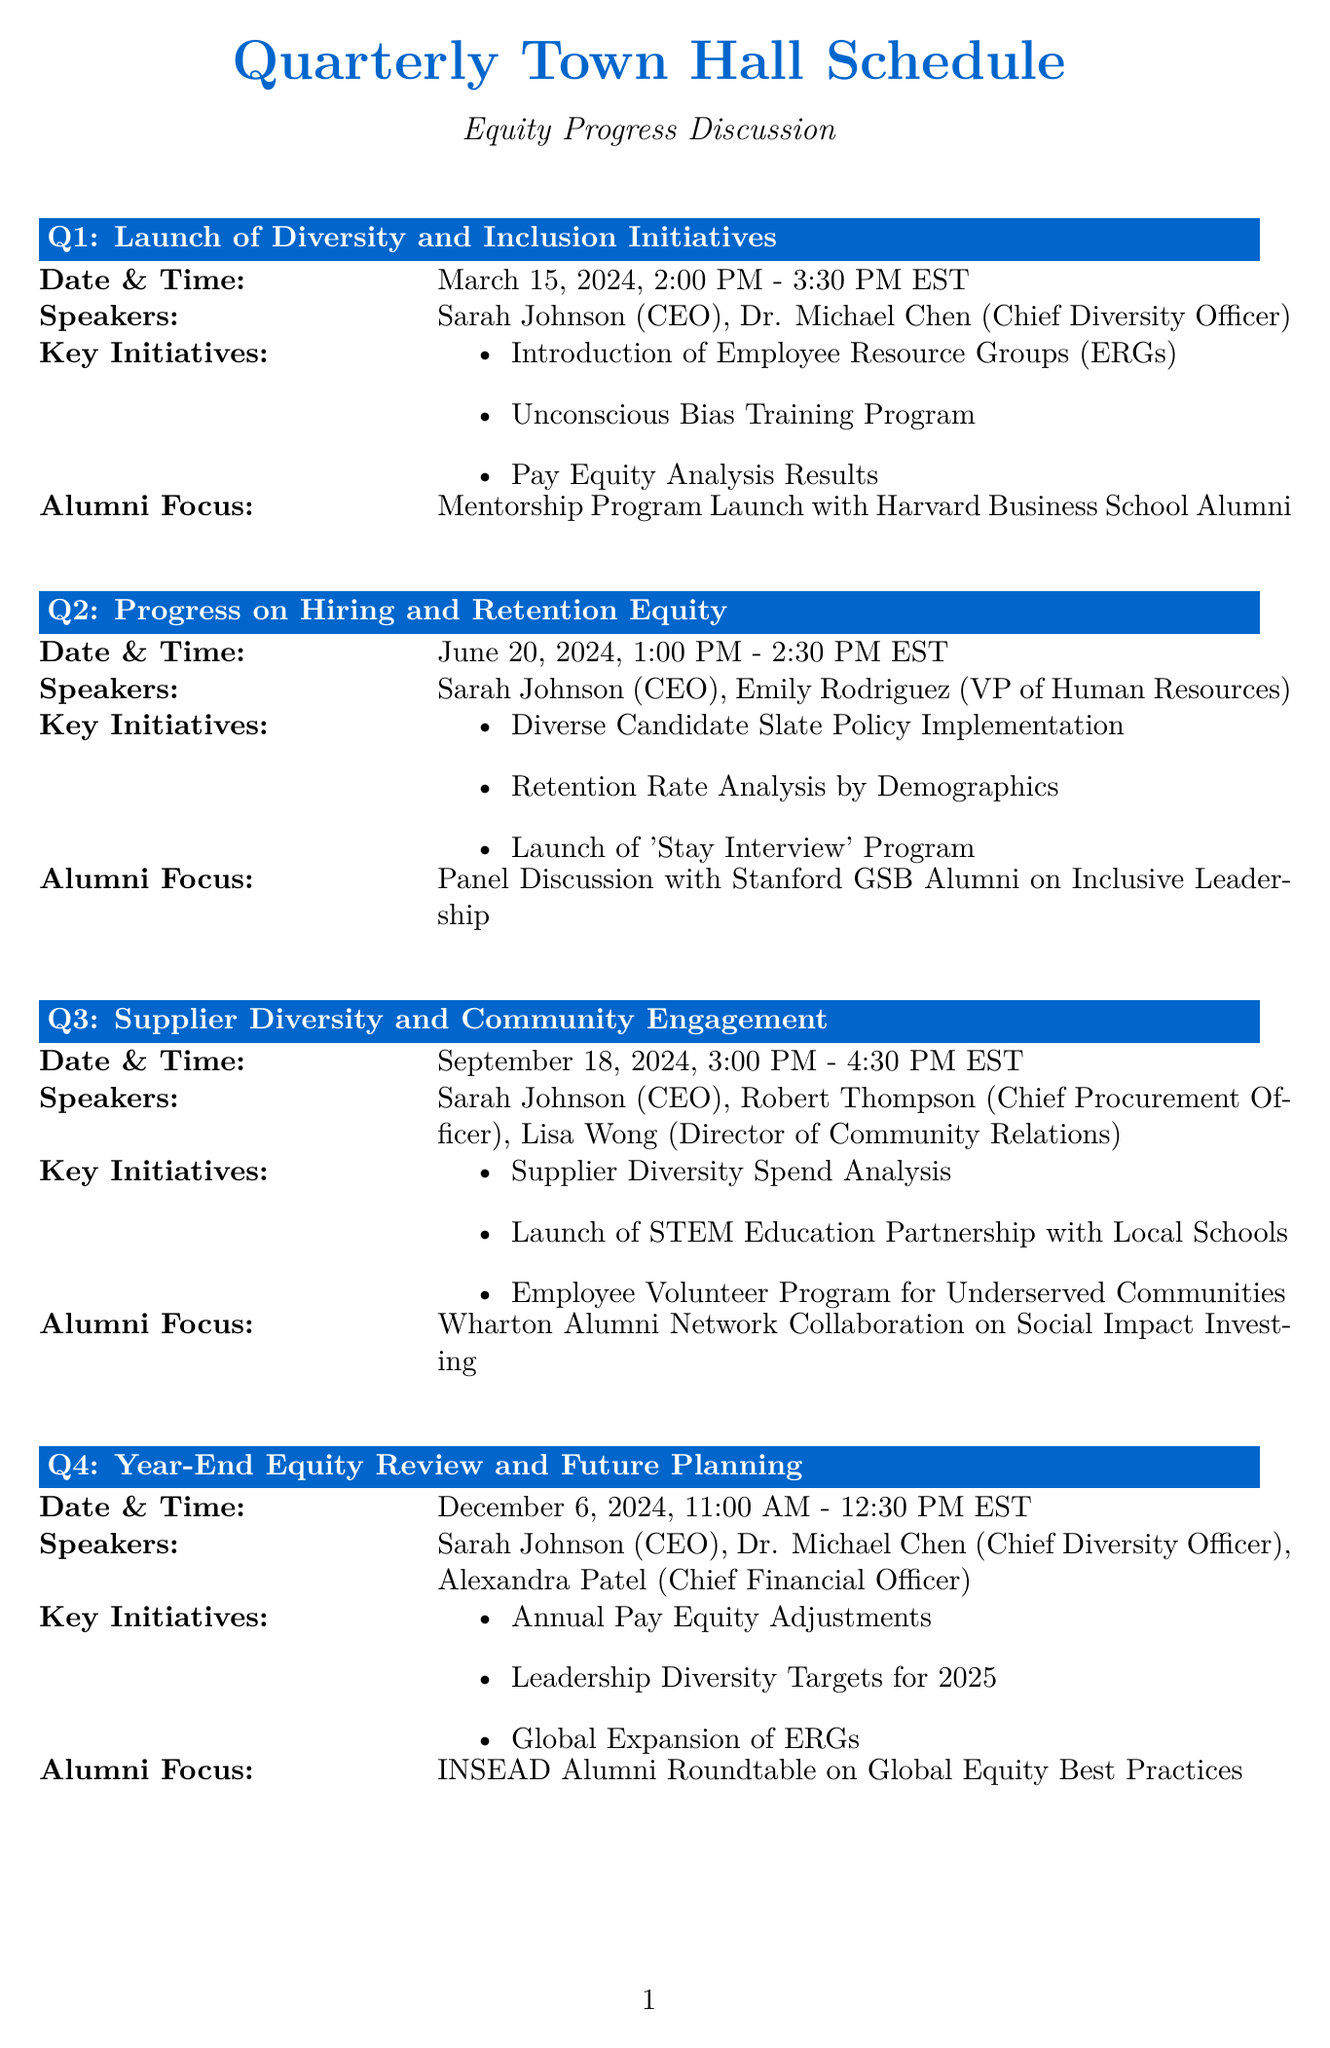what is the date of Q1 town hall? The date for the Q1 town hall is clearly stated in the document.
Answer: March 15, 2024 who is presenting in Q2? The document lists the speakers for each quarter; for Q2, it includes the CEO and VP of Human Resources.
Answer: Sarah Johnson, Emily Rodriguez what is the main topic of Q3? The main topic for each quarterly town hall is listed in the document.
Answer: Supplier Diversity and Community Engagement how long is the Q4 town hall scheduled to last? The duration of the town hall is indicated by the start and end time provided in the schedule.
Answer: 1 hour and 30 minutes which alumni focus is mentioned for Q1? The alumni focus is specified in the key details for each quarterly meeting.
Answer: Mentorship Program Launch with Harvard Business School Alumni what initiative is planned for Q2? The document contains specific key initiatives associated with each quarter.
Answer: Diverse Candidate Slate Policy Implementation how many speakers will present in Q4? The number of speakers can be counted from the list provided for Q4 in the document.
Answer: 3 speakers what is a resource offered in the Additional Resources section? The document enumerates several resources related to equity.
Answer: Equity Dashboard 